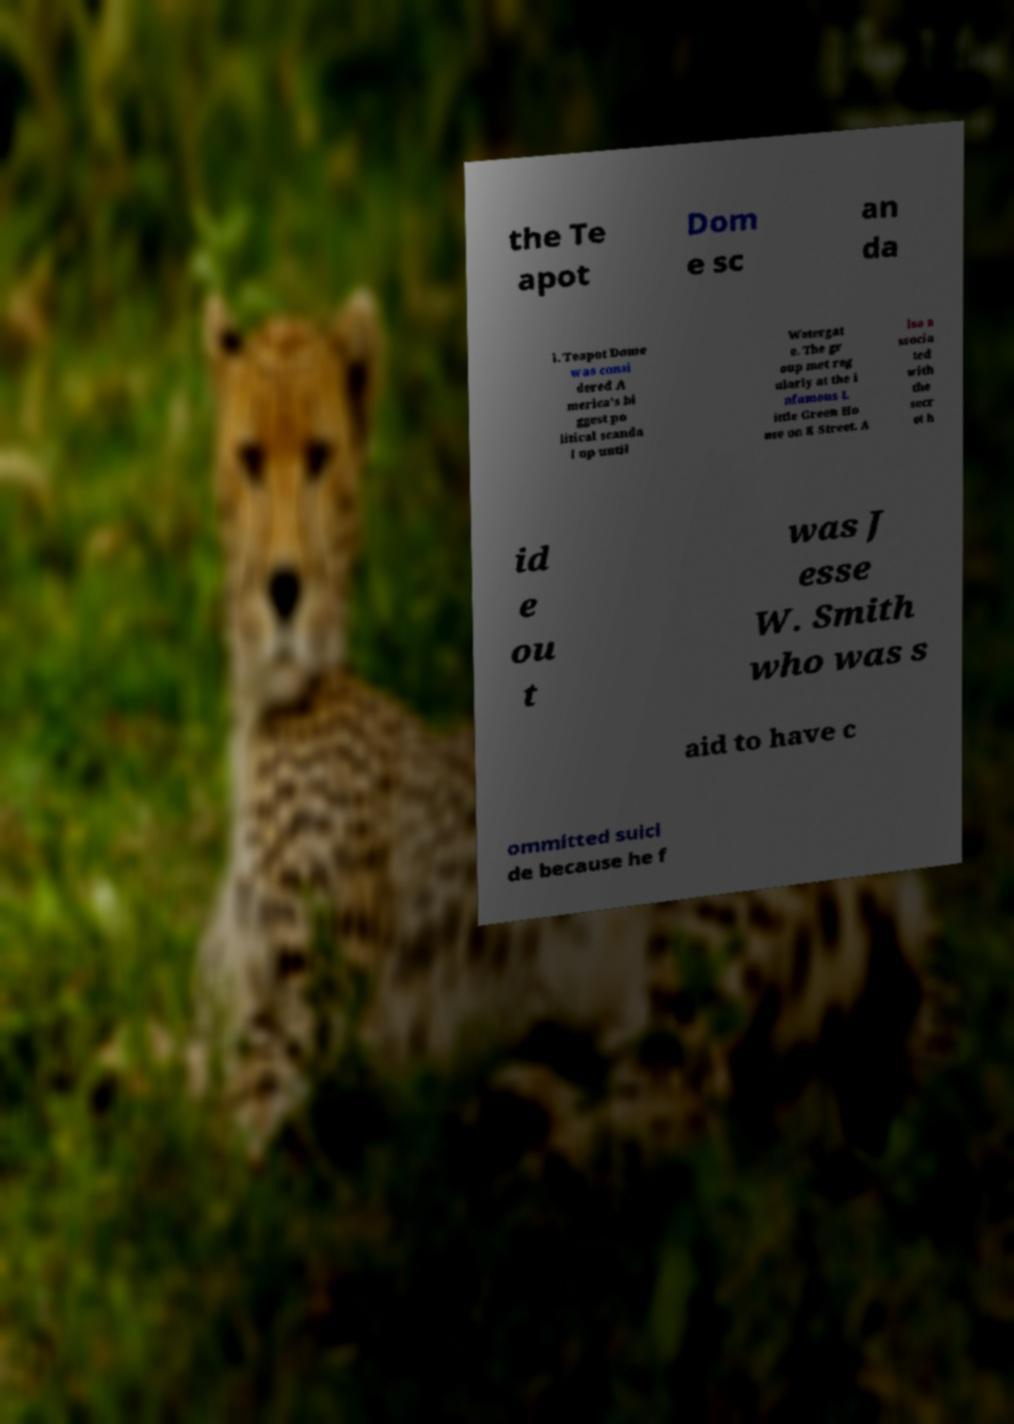There's text embedded in this image that I need extracted. Can you transcribe it verbatim? the Te apot Dom e sc an da l. Teapot Dome was consi dered A merica’s bi ggest po litical scanda l up until Watergat e. The gr oup met reg ularly at the i nfamous L ittle Green Ho use on K Street. A lso a ssocia ted with the secr et h id e ou t was J esse W. Smith who was s aid to have c ommitted suici de because he f 